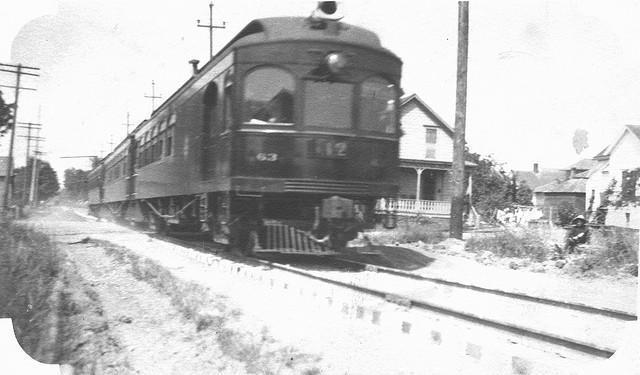How many giraffes are looking at the camera?
Give a very brief answer. 0. 